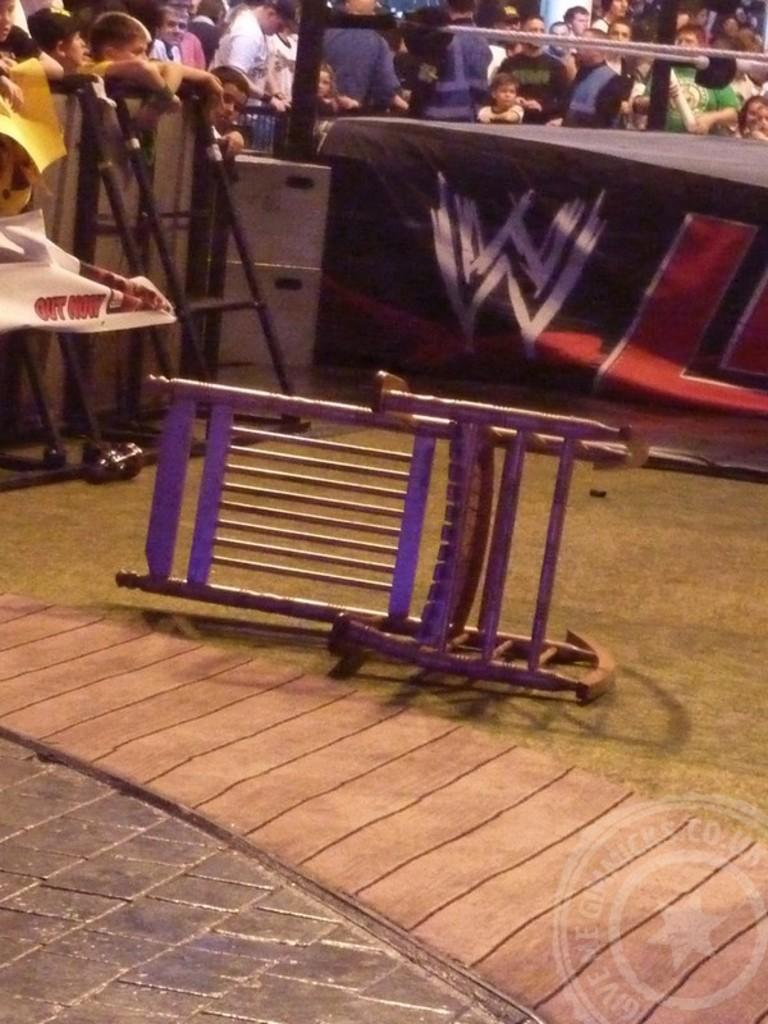How many people are in the image? There is a group of people in the image, but the exact number is not specified. What object can be seen in the image besides the people? There is a chair in the image. What type of crib is visible in the image? There is no crib present in the image. What emotion are the people in the image displaying? The image does not show the emotions of the people, so it cannot be determined from the image. 